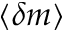Convert formula to latex. <formula><loc_0><loc_0><loc_500><loc_500>\langle \delta m \rangle</formula> 